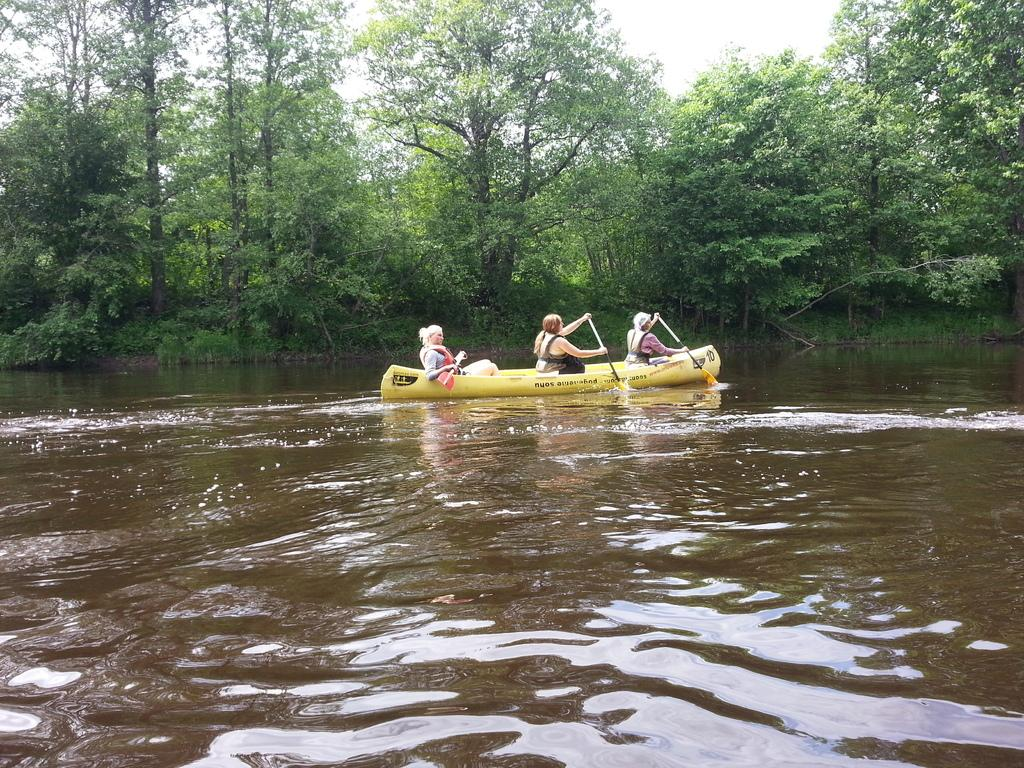How many people are in the image? There are three people in the image. What are the people doing in the image? The people are sitting in a boat and holding pedals in their hands. What can be seen below the boat in the image? There is water visible in the image. What is visible in the background of the image? There are trees in the background of the image. What is the condition of the sky in the image? The sky is cloudy in the image. What grade is the maid ringing the bell for in the students in the image? There is no maid, bell, or students present in the image. The image features three people sitting in a boat and holding pedals. 